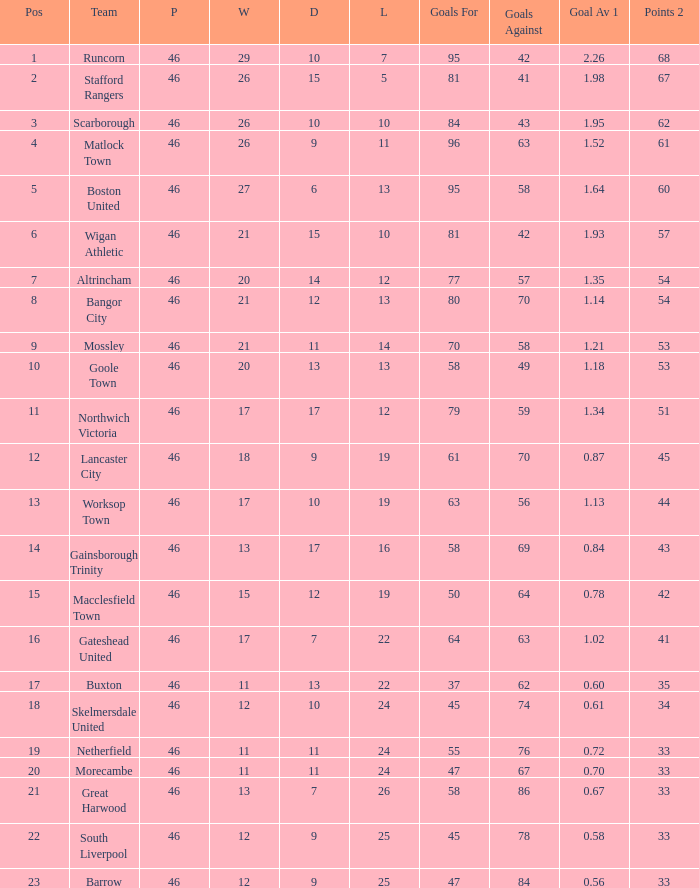How many times did the Lancaster City team play? 1.0. 